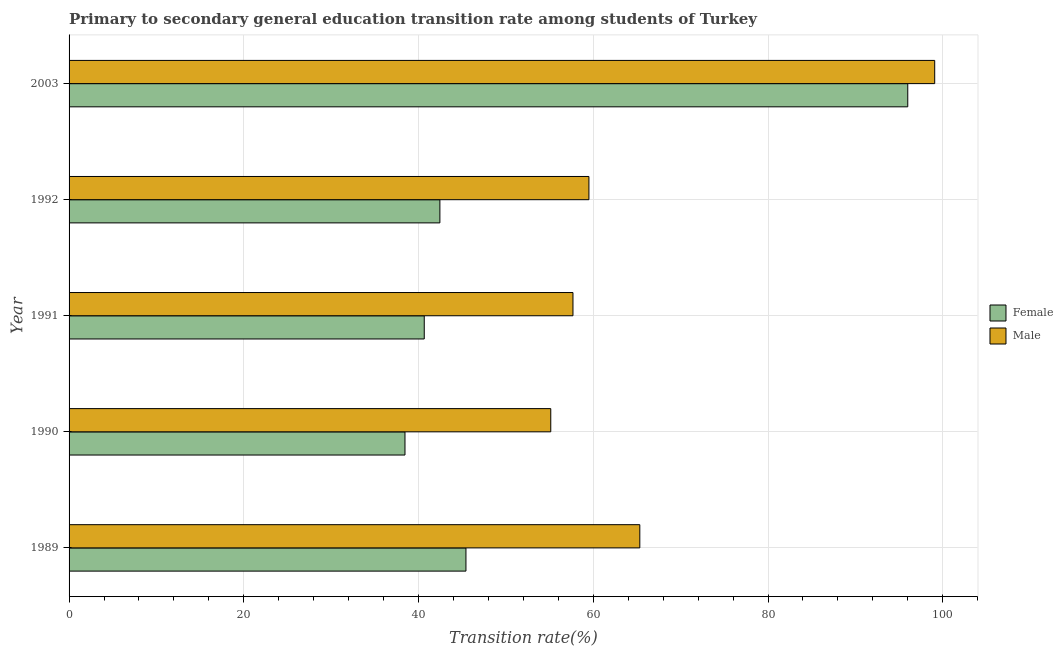How many groups of bars are there?
Your response must be concise. 5. Are the number of bars per tick equal to the number of legend labels?
Provide a short and direct response. Yes. Are the number of bars on each tick of the Y-axis equal?
Your response must be concise. Yes. How many bars are there on the 1st tick from the top?
Offer a terse response. 2. What is the label of the 3rd group of bars from the top?
Provide a short and direct response. 1991. What is the transition rate among female students in 1990?
Give a very brief answer. 38.45. Across all years, what is the maximum transition rate among female students?
Make the answer very short. 96. Across all years, what is the minimum transition rate among male students?
Your answer should be very brief. 55.13. In which year was the transition rate among female students minimum?
Your answer should be compact. 1990. What is the total transition rate among male students in the graph?
Your answer should be very brief. 336.72. What is the difference between the transition rate among female students in 1989 and that in 2003?
Your answer should be very brief. -50.57. What is the difference between the transition rate among male students in 1989 and the transition rate among female students in 1990?
Your answer should be compact. 26.88. What is the average transition rate among male students per year?
Your answer should be very brief. 67.34. In the year 1991, what is the difference between the transition rate among female students and transition rate among male students?
Your answer should be very brief. -17.02. In how many years, is the transition rate among female students greater than 100 %?
Offer a terse response. 0. What is the ratio of the transition rate among female students in 1990 to that in 2003?
Ensure brevity in your answer.  0.4. Is the transition rate among female students in 1990 less than that in 2003?
Give a very brief answer. Yes. Is the difference between the transition rate among female students in 1989 and 2003 greater than the difference between the transition rate among male students in 1989 and 2003?
Your answer should be compact. No. What is the difference between the highest and the second highest transition rate among male students?
Your answer should be compact. 33.75. What is the difference between the highest and the lowest transition rate among male students?
Your answer should be very brief. 43.95. In how many years, is the transition rate among male students greater than the average transition rate among male students taken over all years?
Provide a succinct answer. 1. What does the 2nd bar from the top in 1990 represents?
Make the answer very short. Female. What does the 1st bar from the bottom in 1992 represents?
Provide a succinct answer. Female. Does the graph contain grids?
Your answer should be very brief. Yes. Where does the legend appear in the graph?
Offer a terse response. Center right. How are the legend labels stacked?
Provide a short and direct response. Vertical. What is the title of the graph?
Offer a terse response. Primary to secondary general education transition rate among students of Turkey. Does "Travel services" appear as one of the legend labels in the graph?
Your answer should be compact. No. What is the label or title of the X-axis?
Offer a very short reply. Transition rate(%). What is the Transition rate(%) in Female in 1989?
Your response must be concise. 45.43. What is the Transition rate(%) in Male in 1989?
Offer a very short reply. 65.33. What is the Transition rate(%) of Female in 1990?
Make the answer very short. 38.45. What is the Transition rate(%) in Male in 1990?
Your answer should be very brief. 55.13. What is the Transition rate(%) in Female in 1991?
Offer a very short reply. 40.65. What is the Transition rate(%) in Male in 1991?
Provide a short and direct response. 57.68. What is the Transition rate(%) in Female in 1992?
Provide a short and direct response. 42.44. What is the Transition rate(%) of Male in 1992?
Make the answer very short. 59.5. What is the Transition rate(%) in Female in 2003?
Provide a short and direct response. 96. What is the Transition rate(%) in Male in 2003?
Offer a terse response. 99.08. Across all years, what is the maximum Transition rate(%) of Female?
Make the answer very short. 96. Across all years, what is the maximum Transition rate(%) in Male?
Your answer should be very brief. 99.08. Across all years, what is the minimum Transition rate(%) in Female?
Offer a terse response. 38.45. Across all years, what is the minimum Transition rate(%) of Male?
Make the answer very short. 55.13. What is the total Transition rate(%) of Female in the graph?
Give a very brief answer. 262.97. What is the total Transition rate(%) in Male in the graph?
Provide a succinct answer. 336.72. What is the difference between the Transition rate(%) of Female in 1989 and that in 1990?
Your answer should be compact. 6.98. What is the difference between the Transition rate(%) of Male in 1989 and that in 1990?
Ensure brevity in your answer.  10.19. What is the difference between the Transition rate(%) in Female in 1989 and that in 1991?
Give a very brief answer. 4.77. What is the difference between the Transition rate(%) in Male in 1989 and that in 1991?
Keep it short and to the point. 7.65. What is the difference between the Transition rate(%) of Female in 1989 and that in 1992?
Provide a succinct answer. 2.98. What is the difference between the Transition rate(%) of Male in 1989 and that in 1992?
Your answer should be compact. 5.83. What is the difference between the Transition rate(%) of Female in 1989 and that in 2003?
Ensure brevity in your answer.  -50.57. What is the difference between the Transition rate(%) in Male in 1989 and that in 2003?
Your response must be concise. -33.75. What is the difference between the Transition rate(%) of Female in 1990 and that in 1991?
Give a very brief answer. -2.2. What is the difference between the Transition rate(%) of Male in 1990 and that in 1991?
Your response must be concise. -2.54. What is the difference between the Transition rate(%) of Female in 1990 and that in 1992?
Provide a short and direct response. -3.99. What is the difference between the Transition rate(%) of Male in 1990 and that in 1992?
Provide a succinct answer. -4.37. What is the difference between the Transition rate(%) of Female in 1990 and that in 2003?
Offer a very short reply. -57.55. What is the difference between the Transition rate(%) in Male in 1990 and that in 2003?
Your answer should be very brief. -43.95. What is the difference between the Transition rate(%) of Female in 1991 and that in 1992?
Make the answer very short. -1.79. What is the difference between the Transition rate(%) of Male in 1991 and that in 1992?
Offer a very short reply. -1.83. What is the difference between the Transition rate(%) of Female in 1991 and that in 2003?
Your response must be concise. -55.34. What is the difference between the Transition rate(%) in Male in 1991 and that in 2003?
Keep it short and to the point. -41.4. What is the difference between the Transition rate(%) in Female in 1992 and that in 2003?
Your answer should be very brief. -53.55. What is the difference between the Transition rate(%) in Male in 1992 and that in 2003?
Keep it short and to the point. -39.58. What is the difference between the Transition rate(%) of Female in 1989 and the Transition rate(%) of Male in 1990?
Offer a very short reply. -9.71. What is the difference between the Transition rate(%) in Female in 1989 and the Transition rate(%) in Male in 1991?
Ensure brevity in your answer.  -12.25. What is the difference between the Transition rate(%) in Female in 1989 and the Transition rate(%) in Male in 1992?
Keep it short and to the point. -14.08. What is the difference between the Transition rate(%) of Female in 1989 and the Transition rate(%) of Male in 2003?
Offer a very short reply. -53.65. What is the difference between the Transition rate(%) of Female in 1990 and the Transition rate(%) of Male in 1991?
Give a very brief answer. -19.23. What is the difference between the Transition rate(%) of Female in 1990 and the Transition rate(%) of Male in 1992?
Make the answer very short. -21.05. What is the difference between the Transition rate(%) in Female in 1990 and the Transition rate(%) in Male in 2003?
Make the answer very short. -60.63. What is the difference between the Transition rate(%) of Female in 1991 and the Transition rate(%) of Male in 1992?
Your answer should be compact. -18.85. What is the difference between the Transition rate(%) of Female in 1991 and the Transition rate(%) of Male in 2003?
Your response must be concise. -58.43. What is the difference between the Transition rate(%) of Female in 1992 and the Transition rate(%) of Male in 2003?
Offer a very short reply. -56.64. What is the average Transition rate(%) of Female per year?
Your response must be concise. 52.59. What is the average Transition rate(%) of Male per year?
Provide a short and direct response. 67.34. In the year 1989, what is the difference between the Transition rate(%) of Female and Transition rate(%) of Male?
Provide a short and direct response. -19.9. In the year 1990, what is the difference between the Transition rate(%) in Female and Transition rate(%) in Male?
Offer a terse response. -16.69. In the year 1991, what is the difference between the Transition rate(%) of Female and Transition rate(%) of Male?
Your response must be concise. -17.02. In the year 1992, what is the difference between the Transition rate(%) in Female and Transition rate(%) in Male?
Offer a very short reply. -17.06. In the year 2003, what is the difference between the Transition rate(%) of Female and Transition rate(%) of Male?
Keep it short and to the point. -3.08. What is the ratio of the Transition rate(%) of Female in 1989 to that in 1990?
Provide a short and direct response. 1.18. What is the ratio of the Transition rate(%) of Male in 1989 to that in 1990?
Your response must be concise. 1.18. What is the ratio of the Transition rate(%) of Female in 1989 to that in 1991?
Provide a succinct answer. 1.12. What is the ratio of the Transition rate(%) of Male in 1989 to that in 1991?
Ensure brevity in your answer.  1.13. What is the ratio of the Transition rate(%) of Female in 1989 to that in 1992?
Ensure brevity in your answer.  1.07. What is the ratio of the Transition rate(%) of Male in 1989 to that in 1992?
Ensure brevity in your answer.  1.1. What is the ratio of the Transition rate(%) in Female in 1989 to that in 2003?
Your answer should be compact. 0.47. What is the ratio of the Transition rate(%) in Male in 1989 to that in 2003?
Give a very brief answer. 0.66. What is the ratio of the Transition rate(%) of Female in 1990 to that in 1991?
Your answer should be compact. 0.95. What is the ratio of the Transition rate(%) in Male in 1990 to that in 1991?
Provide a succinct answer. 0.96. What is the ratio of the Transition rate(%) of Female in 1990 to that in 1992?
Provide a succinct answer. 0.91. What is the ratio of the Transition rate(%) in Male in 1990 to that in 1992?
Offer a very short reply. 0.93. What is the ratio of the Transition rate(%) of Female in 1990 to that in 2003?
Offer a terse response. 0.4. What is the ratio of the Transition rate(%) in Male in 1990 to that in 2003?
Provide a succinct answer. 0.56. What is the ratio of the Transition rate(%) in Female in 1991 to that in 1992?
Make the answer very short. 0.96. What is the ratio of the Transition rate(%) in Male in 1991 to that in 1992?
Offer a very short reply. 0.97. What is the ratio of the Transition rate(%) in Female in 1991 to that in 2003?
Provide a short and direct response. 0.42. What is the ratio of the Transition rate(%) in Male in 1991 to that in 2003?
Keep it short and to the point. 0.58. What is the ratio of the Transition rate(%) in Female in 1992 to that in 2003?
Ensure brevity in your answer.  0.44. What is the ratio of the Transition rate(%) of Male in 1992 to that in 2003?
Your answer should be very brief. 0.6. What is the difference between the highest and the second highest Transition rate(%) of Female?
Make the answer very short. 50.57. What is the difference between the highest and the second highest Transition rate(%) in Male?
Provide a succinct answer. 33.75. What is the difference between the highest and the lowest Transition rate(%) of Female?
Offer a terse response. 57.55. What is the difference between the highest and the lowest Transition rate(%) in Male?
Give a very brief answer. 43.95. 